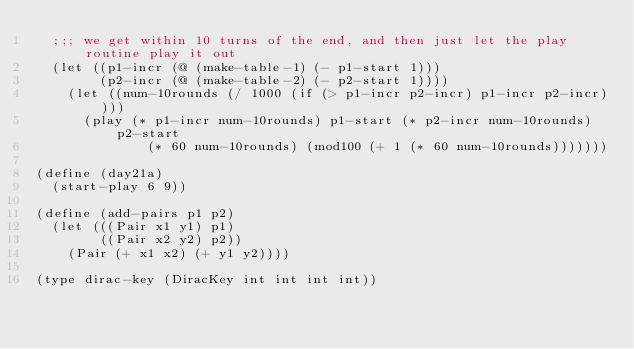Convert code to text. <code><loc_0><loc_0><loc_500><loc_500><_Scheme_>  ;;; we get within 10 turns of the end, and then just let the play routine play it out
  (let ((p1-incr (@ (make-table-1) (- p1-start 1)))
        (p2-incr (@ (make-table-2) (- p2-start 1))))
    (let ((num-10rounds (/ 1000 (if (> p1-incr p2-incr) p1-incr p2-incr))))
      (play (* p1-incr num-10rounds) p1-start (* p2-incr num-10rounds) p2-start
              (* 60 num-10rounds) (mod100 (+ 1 (* 60 num-10rounds)))))))

(define (day21a)
  (start-play 6 9))

(define (add-pairs p1 p2)
  (let (((Pair x1 y1) p1)
        ((Pair x2 y2) p2))
    (Pair (+ x1 x2) (+ y1 y2))))

(type dirac-key (DiracKey int int int int))
</code> 